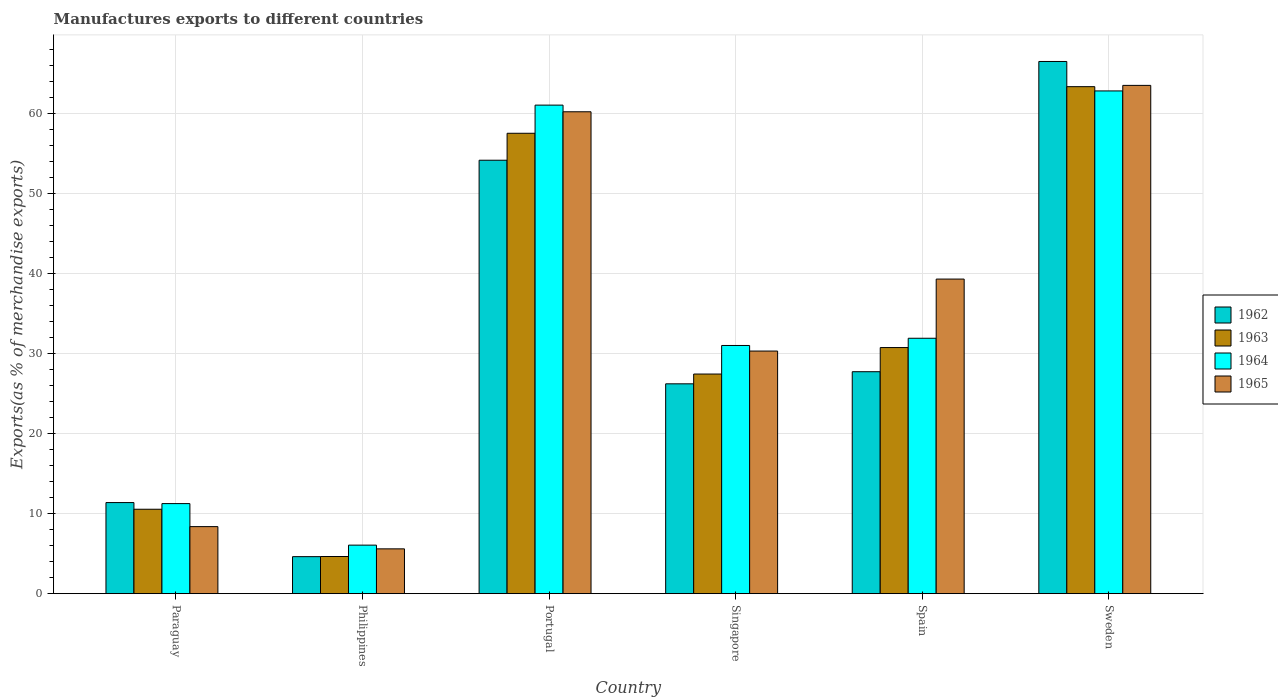How many different coloured bars are there?
Offer a very short reply. 4. How many groups of bars are there?
Provide a succinct answer. 6. Are the number of bars on each tick of the X-axis equal?
Your answer should be compact. Yes. How many bars are there on the 4th tick from the left?
Keep it short and to the point. 4. What is the percentage of exports to different countries in 1964 in Sweden?
Provide a succinct answer. 62.86. Across all countries, what is the maximum percentage of exports to different countries in 1962?
Offer a very short reply. 66.54. Across all countries, what is the minimum percentage of exports to different countries in 1965?
Keep it short and to the point. 5.6. In which country was the percentage of exports to different countries in 1962 minimum?
Your answer should be compact. Philippines. What is the total percentage of exports to different countries in 1965 in the graph?
Your answer should be compact. 207.45. What is the difference between the percentage of exports to different countries in 1965 in Portugal and that in Singapore?
Give a very brief answer. 29.92. What is the difference between the percentage of exports to different countries in 1965 in Philippines and the percentage of exports to different countries in 1964 in Spain?
Your answer should be very brief. -26.33. What is the average percentage of exports to different countries in 1963 per country?
Give a very brief answer. 32.4. What is the difference between the percentage of exports to different countries of/in 1962 and percentage of exports to different countries of/in 1963 in Paraguay?
Keep it short and to the point. 0.83. In how many countries, is the percentage of exports to different countries in 1965 greater than 54 %?
Ensure brevity in your answer.  2. What is the ratio of the percentage of exports to different countries in 1965 in Paraguay to that in Portugal?
Your answer should be very brief. 0.14. Is the difference between the percentage of exports to different countries in 1962 in Portugal and Spain greater than the difference between the percentage of exports to different countries in 1963 in Portugal and Spain?
Provide a short and direct response. No. What is the difference between the highest and the second highest percentage of exports to different countries in 1964?
Your response must be concise. -1.77. What is the difference between the highest and the lowest percentage of exports to different countries in 1963?
Give a very brief answer. 58.74. Is the sum of the percentage of exports to different countries in 1963 in Singapore and Spain greater than the maximum percentage of exports to different countries in 1965 across all countries?
Make the answer very short. No. What does the 4th bar from the left in Singapore represents?
Your response must be concise. 1965. What does the 1st bar from the right in Portugal represents?
Provide a short and direct response. 1965. Is it the case that in every country, the sum of the percentage of exports to different countries in 1962 and percentage of exports to different countries in 1963 is greater than the percentage of exports to different countries in 1965?
Your response must be concise. Yes. Are the values on the major ticks of Y-axis written in scientific E-notation?
Provide a succinct answer. No. Does the graph contain any zero values?
Your answer should be very brief. No. Does the graph contain grids?
Keep it short and to the point. Yes. How are the legend labels stacked?
Your answer should be very brief. Vertical. What is the title of the graph?
Ensure brevity in your answer.  Manufactures exports to different countries. Does "1992" appear as one of the legend labels in the graph?
Make the answer very short. No. What is the label or title of the Y-axis?
Provide a succinct answer. Exports(as % of merchandise exports). What is the Exports(as % of merchandise exports) of 1962 in Paraguay?
Make the answer very short. 11.39. What is the Exports(as % of merchandise exports) of 1963 in Paraguay?
Offer a very short reply. 10.55. What is the Exports(as % of merchandise exports) of 1964 in Paraguay?
Give a very brief answer. 11.26. What is the Exports(as % of merchandise exports) in 1965 in Paraguay?
Provide a short and direct response. 8.38. What is the Exports(as % of merchandise exports) of 1962 in Philippines?
Provide a short and direct response. 4.63. What is the Exports(as % of merchandise exports) in 1963 in Philippines?
Keep it short and to the point. 4.64. What is the Exports(as % of merchandise exports) of 1964 in Philippines?
Keep it short and to the point. 6.07. What is the Exports(as % of merchandise exports) in 1965 in Philippines?
Provide a succinct answer. 5.6. What is the Exports(as % of merchandise exports) in 1962 in Portugal?
Offer a terse response. 54.19. What is the Exports(as % of merchandise exports) in 1963 in Portugal?
Provide a succinct answer. 57.56. What is the Exports(as % of merchandise exports) of 1964 in Portugal?
Keep it short and to the point. 61.08. What is the Exports(as % of merchandise exports) of 1965 in Portugal?
Give a very brief answer. 60.25. What is the Exports(as % of merchandise exports) of 1962 in Singapore?
Provide a short and direct response. 26.24. What is the Exports(as % of merchandise exports) in 1963 in Singapore?
Give a very brief answer. 27.46. What is the Exports(as % of merchandise exports) in 1964 in Singapore?
Offer a very short reply. 31.03. What is the Exports(as % of merchandise exports) in 1965 in Singapore?
Your response must be concise. 30.33. What is the Exports(as % of merchandise exports) in 1962 in Spain?
Offer a very short reply. 27.75. What is the Exports(as % of merchandise exports) in 1963 in Spain?
Offer a very short reply. 30.77. What is the Exports(as % of merchandise exports) of 1964 in Spain?
Offer a very short reply. 31.93. What is the Exports(as % of merchandise exports) in 1965 in Spain?
Provide a succinct answer. 39.33. What is the Exports(as % of merchandise exports) of 1962 in Sweden?
Give a very brief answer. 66.54. What is the Exports(as % of merchandise exports) of 1963 in Sweden?
Your response must be concise. 63.39. What is the Exports(as % of merchandise exports) in 1964 in Sweden?
Ensure brevity in your answer.  62.86. What is the Exports(as % of merchandise exports) in 1965 in Sweden?
Offer a very short reply. 63.55. Across all countries, what is the maximum Exports(as % of merchandise exports) in 1962?
Your answer should be compact. 66.54. Across all countries, what is the maximum Exports(as % of merchandise exports) of 1963?
Offer a very short reply. 63.39. Across all countries, what is the maximum Exports(as % of merchandise exports) of 1964?
Make the answer very short. 62.86. Across all countries, what is the maximum Exports(as % of merchandise exports) of 1965?
Ensure brevity in your answer.  63.55. Across all countries, what is the minimum Exports(as % of merchandise exports) of 1962?
Provide a succinct answer. 4.63. Across all countries, what is the minimum Exports(as % of merchandise exports) of 1963?
Ensure brevity in your answer.  4.64. Across all countries, what is the minimum Exports(as % of merchandise exports) of 1964?
Your answer should be very brief. 6.07. Across all countries, what is the minimum Exports(as % of merchandise exports) of 1965?
Your answer should be compact. 5.6. What is the total Exports(as % of merchandise exports) in 1962 in the graph?
Your response must be concise. 190.73. What is the total Exports(as % of merchandise exports) of 1963 in the graph?
Ensure brevity in your answer.  194.38. What is the total Exports(as % of merchandise exports) in 1964 in the graph?
Offer a terse response. 204.23. What is the total Exports(as % of merchandise exports) of 1965 in the graph?
Your answer should be very brief. 207.45. What is the difference between the Exports(as % of merchandise exports) of 1962 in Paraguay and that in Philippines?
Keep it short and to the point. 6.76. What is the difference between the Exports(as % of merchandise exports) in 1963 in Paraguay and that in Philippines?
Provide a short and direct response. 5.91. What is the difference between the Exports(as % of merchandise exports) of 1964 in Paraguay and that in Philippines?
Your answer should be very brief. 5.19. What is the difference between the Exports(as % of merchandise exports) in 1965 in Paraguay and that in Philippines?
Offer a very short reply. 2.78. What is the difference between the Exports(as % of merchandise exports) in 1962 in Paraguay and that in Portugal?
Keep it short and to the point. -42.8. What is the difference between the Exports(as % of merchandise exports) of 1963 in Paraguay and that in Portugal?
Ensure brevity in your answer.  -47.01. What is the difference between the Exports(as % of merchandise exports) in 1964 in Paraguay and that in Portugal?
Provide a short and direct response. -49.82. What is the difference between the Exports(as % of merchandise exports) of 1965 in Paraguay and that in Portugal?
Ensure brevity in your answer.  -51.87. What is the difference between the Exports(as % of merchandise exports) of 1962 in Paraguay and that in Singapore?
Make the answer very short. -14.85. What is the difference between the Exports(as % of merchandise exports) of 1963 in Paraguay and that in Singapore?
Provide a short and direct response. -16.91. What is the difference between the Exports(as % of merchandise exports) of 1964 in Paraguay and that in Singapore?
Ensure brevity in your answer.  -19.77. What is the difference between the Exports(as % of merchandise exports) of 1965 in Paraguay and that in Singapore?
Ensure brevity in your answer.  -21.95. What is the difference between the Exports(as % of merchandise exports) in 1962 in Paraguay and that in Spain?
Your answer should be very brief. -16.36. What is the difference between the Exports(as % of merchandise exports) of 1963 in Paraguay and that in Spain?
Your answer should be very brief. -20.22. What is the difference between the Exports(as % of merchandise exports) of 1964 in Paraguay and that in Spain?
Your answer should be very brief. -20.67. What is the difference between the Exports(as % of merchandise exports) in 1965 in Paraguay and that in Spain?
Your answer should be very brief. -30.95. What is the difference between the Exports(as % of merchandise exports) of 1962 in Paraguay and that in Sweden?
Offer a terse response. -55.15. What is the difference between the Exports(as % of merchandise exports) in 1963 in Paraguay and that in Sweden?
Offer a terse response. -52.83. What is the difference between the Exports(as % of merchandise exports) of 1964 in Paraguay and that in Sweden?
Ensure brevity in your answer.  -51.6. What is the difference between the Exports(as % of merchandise exports) in 1965 in Paraguay and that in Sweden?
Your response must be concise. -55.17. What is the difference between the Exports(as % of merchandise exports) of 1962 in Philippines and that in Portugal?
Your answer should be compact. -49.57. What is the difference between the Exports(as % of merchandise exports) of 1963 in Philippines and that in Portugal?
Provide a short and direct response. -52.92. What is the difference between the Exports(as % of merchandise exports) of 1964 in Philippines and that in Portugal?
Make the answer very short. -55.02. What is the difference between the Exports(as % of merchandise exports) of 1965 in Philippines and that in Portugal?
Keep it short and to the point. -54.65. What is the difference between the Exports(as % of merchandise exports) in 1962 in Philippines and that in Singapore?
Provide a succinct answer. -21.61. What is the difference between the Exports(as % of merchandise exports) in 1963 in Philippines and that in Singapore?
Your answer should be very brief. -22.82. What is the difference between the Exports(as % of merchandise exports) in 1964 in Philippines and that in Singapore?
Offer a terse response. -24.96. What is the difference between the Exports(as % of merchandise exports) of 1965 in Philippines and that in Singapore?
Provide a short and direct response. -24.73. What is the difference between the Exports(as % of merchandise exports) of 1962 in Philippines and that in Spain?
Your answer should be very brief. -23.12. What is the difference between the Exports(as % of merchandise exports) in 1963 in Philippines and that in Spain?
Provide a succinct answer. -26.13. What is the difference between the Exports(as % of merchandise exports) of 1964 in Philippines and that in Spain?
Your response must be concise. -25.87. What is the difference between the Exports(as % of merchandise exports) of 1965 in Philippines and that in Spain?
Ensure brevity in your answer.  -33.73. What is the difference between the Exports(as % of merchandise exports) of 1962 in Philippines and that in Sweden?
Your response must be concise. -61.91. What is the difference between the Exports(as % of merchandise exports) in 1963 in Philippines and that in Sweden?
Your response must be concise. -58.74. What is the difference between the Exports(as % of merchandise exports) in 1964 in Philippines and that in Sweden?
Provide a short and direct response. -56.79. What is the difference between the Exports(as % of merchandise exports) of 1965 in Philippines and that in Sweden?
Provide a short and direct response. -57.95. What is the difference between the Exports(as % of merchandise exports) of 1962 in Portugal and that in Singapore?
Provide a short and direct response. 27.96. What is the difference between the Exports(as % of merchandise exports) in 1963 in Portugal and that in Singapore?
Ensure brevity in your answer.  30.1. What is the difference between the Exports(as % of merchandise exports) in 1964 in Portugal and that in Singapore?
Keep it short and to the point. 30.05. What is the difference between the Exports(as % of merchandise exports) of 1965 in Portugal and that in Singapore?
Your answer should be compact. 29.92. What is the difference between the Exports(as % of merchandise exports) of 1962 in Portugal and that in Spain?
Provide a short and direct response. 26.44. What is the difference between the Exports(as % of merchandise exports) in 1963 in Portugal and that in Spain?
Ensure brevity in your answer.  26.79. What is the difference between the Exports(as % of merchandise exports) of 1964 in Portugal and that in Spain?
Provide a short and direct response. 29.15. What is the difference between the Exports(as % of merchandise exports) in 1965 in Portugal and that in Spain?
Provide a short and direct response. 20.92. What is the difference between the Exports(as % of merchandise exports) in 1962 in Portugal and that in Sweden?
Your response must be concise. -12.35. What is the difference between the Exports(as % of merchandise exports) in 1963 in Portugal and that in Sweden?
Your answer should be compact. -5.83. What is the difference between the Exports(as % of merchandise exports) of 1964 in Portugal and that in Sweden?
Your answer should be very brief. -1.77. What is the difference between the Exports(as % of merchandise exports) in 1965 in Portugal and that in Sweden?
Provide a short and direct response. -3.3. What is the difference between the Exports(as % of merchandise exports) of 1962 in Singapore and that in Spain?
Ensure brevity in your answer.  -1.51. What is the difference between the Exports(as % of merchandise exports) in 1963 in Singapore and that in Spain?
Your response must be concise. -3.31. What is the difference between the Exports(as % of merchandise exports) of 1964 in Singapore and that in Spain?
Provide a short and direct response. -0.9. What is the difference between the Exports(as % of merchandise exports) in 1965 in Singapore and that in Spain?
Your response must be concise. -9. What is the difference between the Exports(as % of merchandise exports) in 1962 in Singapore and that in Sweden?
Provide a short and direct response. -40.3. What is the difference between the Exports(as % of merchandise exports) in 1963 in Singapore and that in Sweden?
Offer a very short reply. -35.93. What is the difference between the Exports(as % of merchandise exports) of 1964 in Singapore and that in Sweden?
Offer a very short reply. -31.83. What is the difference between the Exports(as % of merchandise exports) of 1965 in Singapore and that in Sweden?
Offer a very short reply. -33.22. What is the difference between the Exports(as % of merchandise exports) in 1962 in Spain and that in Sweden?
Provide a succinct answer. -38.79. What is the difference between the Exports(as % of merchandise exports) in 1963 in Spain and that in Sweden?
Give a very brief answer. -32.62. What is the difference between the Exports(as % of merchandise exports) in 1964 in Spain and that in Sweden?
Offer a very short reply. -30.92. What is the difference between the Exports(as % of merchandise exports) of 1965 in Spain and that in Sweden?
Your answer should be compact. -24.22. What is the difference between the Exports(as % of merchandise exports) in 1962 in Paraguay and the Exports(as % of merchandise exports) in 1963 in Philippines?
Keep it short and to the point. 6.75. What is the difference between the Exports(as % of merchandise exports) of 1962 in Paraguay and the Exports(as % of merchandise exports) of 1964 in Philippines?
Provide a short and direct response. 5.32. What is the difference between the Exports(as % of merchandise exports) of 1962 in Paraguay and the Exports(as % of merchandise exports) of 1965 in Philippines?
Provide a succinct answer. 5.79. What is the difference between the Exports(as % of merchandise exports) in 1963 in Paraguay and the Exports(as % of merchandise exports) in 1964 in Philippines?
Your answer should be compact. 4.49. What is the difference between the Exports(as % of merchandise exports) in 1963 in Paraguay and the Exports(as % of merchandise exports) in 1965 in Philippines?
Offer a terse response. 4.95. What is the difference between the Exports(as % of merchandise exports) of 1964 in Paraguay and the Exports(as % of merchandise exports) of 1965 in Philippines?
Provide a short and direct response. 5.66. What is the difference between the Exports(as % of merchandise exports) of 1962 in Paraguay and the Exports(as % of merchandise exports) of 1963 in Portugal?
Provide a succinct answer. -46.17. What is the difference between the Exports(as % of merchandise exports) in 1962 in Paraguay and the Exports(as % of merchandise exports) in 1964 in Portugal?
Your answer should be compact. -49.69. What is the difference between the Exports(as % of merchandise exports) of 1962 in Paraguay and the Exports(as % of merchandise exports) of 1965 in Portugal?
Provide a short and direct response. -48.86. What is the difference between the Exports(as % of merchandise exports) in 1963 in Paraguay and the Exports(as % of merchandise exports) in 1964 in Portugal?
Your answer should be compact. -50.53. What is the difference between the Exports(as % of merchandise exports) in 1963 in Paraguay and the Exports(as % of merchandise exports) in 1965 in Portugal?
Keep it short and to the point. -49.7. What is the difference between the Exports(as % of merchandise exports) in 1964 in Paraguay and the Exports(as % of merchandise exports) in 1965 in Portugal?
Your response must be concise. -48.99. What is the difference between the Exports(as % of merchandise exports) of 1962 in Paraguay and the Exports(as % of merchandise exports) of 1963 in Singapore?
Give a very brief answer. -16.07. What is the difference between the Exports(as % of merchandise exports) in 1962 in Paraguay and the Exports(as % of merchandise exports) in 1964 in Singapore?
Offer a very short reply. -19.64. What is the difference between the Exports(as % of merchandise exports) in 1962 in Paraguay and the Exports(as % of merchandise exports) in 1965 in Singapore?
Your response must be concise. -18.94. What is the difference between the Exports(as % of merchandise exports) in 1963 in Paraguay and the Exports(as % of merchandise exports) in 1964 in Singapore?
Your answer should be very brief. -20.48. What is the difference between the Exports(as % of merchandise exports) of 1963 in Paraguay and the Exports(as % of merchandise exports) of 1965 in Singapore?
Provide a short and direct response. -19.78. What is the difference between the Exports(as % of merchandise exports) in 1964 in Paraguay and the Exports(as % of merchandise exports) in 1965 in Singapore?
Offer a very short reply. -19.07. What is the difference between the Exports(as % of merchandise exports) of 1962 in Paraguay and the Exports(as % of merchandise exports) of 1963 in Spain?
Keep it short and to the point. -19.38. What is the difference between the Exports(as % of merchandise exports) in 1962 in Paraguay and the Exports(as % of merchandise exports) in 1964 in Spain?
Provide a short and direct response. -20.54. What is the difference between the Exports(as % of merchandise exports) in 1962 in Paraguay and the Exports(as % of merchandise exports) in 1965 in Spain?
Your answer should be very brief. -27.94. What is the difference between the Exports(as % of merchandise exports) of 1963 in Paraguay and the Exports(as % of merchandise exports) of 1964 in Spain?
Your answer should be very brief. -21.38. What is the difference between the Exports(as % of merchandise exports) of 1963 in Paraguay and the Exports(as % of merchandise exports) of 1965 in Spain?
Provide a succinct answer. -28.78. What is the difference between the Exports(as % of merchandise exports) in 1964 in Paraguay and the Exports(as % of merchandise exports) in 1965 in Spain?
Provide a succinct answer. -28.07. What is the difference between the Exports(as % of merchandise exports) in 1962 in Paraguay and the Exports(as % of merchandise exports) in 1963 in Sweden?
Keep it short and to the point. -52. What is the difference between the Exports(as % of merchandise exports) in 1962 in Paraguay and the Exports(as % of merchandise exports) in 1964 in Sweden?
Make the answer very short. -51.47. What is the difference between the Exports(as % of merchandise exports) of 1962 in Paraguay and the Exports(as % of merchandise exports) of 1965 in Sweden?
Offer a terse response. -52.16. What is the difference between the Exports(as % of merchandise exports) of 1963 in Paraguay and the Exports(as % of merchandise exports) of 1964 in Sweden?
Provide a short and direct response. -52.3. What is the difference between the Exports(as % of merchandise exports) in 1963 in Paraguay and the Exports(as % of merchandise exports) in 1965 in Sweden?
Offer a terse response. -52.99. What is the difference between the Exports(as % of merchandise exports) of 1964 in Paraguay and the Exports(as % of merchandise exports) of 1965 in Sweden?
Provide a short and direct response. -52.29. What is the difference between the Exports(as % of merchandise exports) of 1962 in Philippines and the Exports(as % of merchandise exports) of 1963 in Portugal?
Your answer should be compact. -52.93. What is the difference between the Exports(as % of merchandise exports) in 1962 in Philippines and the Exports(as % of merchandise exports) in 1964 in Portugal?
Ensure brevity in your answer.  -56.46. What is the difference between the Exports(as % of merchandise exports) in 1962 in Philippines and the Exports(as % of merchandise exports) in 1965 in Portugal?
Offer a very short reply. -55.62. What is the difference between the Exports(as % of merchandise exports) of 1963 in Philippines and the Exports(as % of merchandise exports) of 1964 in Portugal?
Make the answer very short. -56.44. What is the difference between the Exports(as % of merchandise exports) in 1963 in Philippines and the Exports(as % of merchandise exports) in 1965 in Portugal?
Offer a very short reply. -55.61. What is the difference between the Exports(as % of merchandise exports) of 1964 in Philippines and the Exports(as % of merchandise exports) of 1965 in Portugal?
Ensure brevity in your answer.  -54.18. What is the difference between the Exports(as % of merchandise exports) of 1962 in Philippines and the Exports(as % of merchandise exports) of 1963 in Singapore?
Provide a short and direct response. -22.83. What is the difference between the Exports(as % of merchandise exports) of 1962 in Philippines and the Exports(as % of merchandise exports) of 1964 in Singapore?
Provide a succinct answer. -26.4. What is the difference between the Exports(as % of merchandise exports) of 1962 in Philippines and the Exports(as % of merchandise exports) of 1965 in Singapore?
Your answer should be compact. -25.7. What is the difference between the Exports(as % of merchandise exports) in 1963 in Philippines and the Exports(as % of merchandise exports) in 1964 in Singapore?
Provide a short and direct response. -26.39. What is the difference between the Exports(as % of merchandise exports) in 1963 in Philippines and the Exports(as % of merchandise exports) in 1965 in Singapore?
Provide a short and direct response. -25.69. What is the difference between the Exports(as % of merchandise exports) in 1964 in Philippines and the Exports(as % of merchandise exports) in 1965 in Singapore?
Provide a succinct answer. -24.27. What is the difference between the Exports(as % of merchandise exports) of 1962 in Philippines and the Exports(as % of merchandise exports) of 1963 in Spain?
Provide a short and direct response. -26.14. What is the difference between the Exports(as % of merchandise exports) of 1962 in Philippines and the Exports(as % of merchandise exports) of 1964 in Spain?
Keep it short and to the point. -27.31. What is the difference between the Exports(as % of merchandise exports) of 1962 in Philippines and the Exports(as % of merchandise exports) of 1965 in Spain?
Give a very brief answer. -34.71. What is the difference between the Exports(as % of merchandise exports) of 1963 in Philippines and the Exports(as % of merchandise exports) of 1964 in Spain?
Give a very brief answer. -27.29. What is the difference between the Exports(as % of merchandise exports) of 1963 in Philippines and the Exports(as % of merchandise exports) of 1965 in Spain?
Make the answer very short. -34.69. What is the difference between the Exports(as % of merchandise exports) of 1964 in Philippines and the Exports(as % of merchandise exports) of 1965 in Spain?
Offer a very short reply. -33.27. What is the difference between the Exports(as % of merchandise exports) in 1962 in Philippines and the Exports(as % of merchandise exports) in 1963 in Sweden?
Make the answer very short. -58.76. What is the difference between the Exports(as % of merchandise exports) in 1962 in Philippines and the Exports(as % of merchandise exports) in 1964 in Sweden?
Provide a succinct answer. -58.23. What is the difference between the Exports(as % of merchandise exports) in 1962 in Philippines and the Exports(as % of merchandise exports) in 1965 in Sweden?
Give a very brief answer. -58.92. What is the difference between the Exports(as % of merchandise exports) in 1963 in Philippines and the Exports(as % of merchandise exports) in 1964 in Sweden?
Give a very brief answer. -58.21. What is the difference between the Exports(as % of merchandise exports) of 1963 in Philippines and the Exports(as % of merchandise exports) of 1965 in Sweden?
Provide a succinct answer. -58.91. What is the difference between the Exports(as % of merchandise exports) of 1964 in Philippines and the Exports(as % of merchandise exports) of 1965 in Sweden?
Your response must be concise. -57.48. What is the difference between the Exports(as % of merchandise exports) in 1962 in Portugal and the Exports(as % of merchandise exports) in 1963 in Singapore?
Provide a succinct answer. 26.73. What is the difference between the Exports(as % of merchandise exports) in 1962 in Portugal and the Exports(as % of merchandise exports) in 1964 in Singapore?
Your answer should be very brief. 23.16. What is the difference between the Exports(as % of merchandise exports) of 1962 in Portugal and the Exports(as % of merchandise exports) of 1965 in Singapore?
Your answer should be compact. 23.86. What is the difference between the Exports(as % of merchandise exports) of 1963 in Portugal and the Exports(as % of merchandise exports) of 1964 in Singapore?
Offer a very short reply. 26.53. What is the difference between the Exports(as % of merchandise exports) of 1963 in Portugal and the Exports(as % of merchandise exports) of 1965 in Singapore?
Offer a very short reply. 27.23. What is the difference between the Exports(as % of merchandise exports) of 1964 in Portugal and the Exports(as % of merchandise exports) of 1965 in Singapore?
Offer a terse response. 30.75. What is the difference between the Exports(as % of merchandise exports) in 1962 in Portugal and the Exports(as % of merchandise exports) in 1963 in Spain?
Your answer should be very brief. 23.42. What is the difference between the Exports(as % of merchandise exports) in 1962 in Portugal and the Exports(as % of merchandise exports) in 1964 in Spain?
Keep it short and to the point. 22.26. What is the difference between the Exports(as % of merchandise exports) in 1962 in Portugal and the Exports(as % of merchandise exports) in 1965 in Spain?
Offer a very short reply. 14.86. What is the difference between the Exports(as % of merchandise exports) in 1963 in Portugal and the Exports(as % of merchandise exports) in 1964 in Spain?
Your answer should be very brief. 25.63. What is the difference between the Exports(as % of merchandise exports) of 1963 in Portugal and the Exports(as % of merchandise exports) of 1965 in Spain?
Provide a short and direct response. 18.23. What is the difference between the Exports(as % of merchandise exports) in 1964 in Portugal and the Exports(as % of merchandise exports) in 1965 in Spain?
Keep it short and to the point. 21.75. What is the difference between the Exports(as % of merchandise exports) of 1962 in Portugal and the Exports(as % of merchandise exports) of 1963 in Sweden?
Make the answer very short. -9.2. What is the difference between the Exports(as % of merchandise exports) of 1962 in Portugal and the Exports(as % of merchandise exports) of 1964 in Sweden?
Ensure brevity in your answer.  -8.66. What is the difference between the Exports(as % of merchandise exports) in 1962 in Portugal and the Exports(as % of merchandise exports) in 1965 in Sweden?
Offer a terse response. -9.36. What is the difference between the Exports(as % of merchandise exports) in 1963 in Portugal and the Exports(as % of merchandise exports) in 1964 in Sweden?
Offer a terse response. -5.3. What is the difference between the Exports(as % of merchandise exports) of 1963 in Portugal and the Exports(as % of merchandise exports) of 1965 in Sweden?
Provide a succinct answer. -5.99. What is the difference between the Exports(as % of merchandise exports) of 1964 in Portugal and the Exports(as % of merchandise exports) of 1965 in Sweden?
Ensure brevity in your answer.  -2.47. What is the difference between the Exports(as % of merchandise exports) of 1962 in Singapore and the Exports(as % of merchandise exports) of 1963 in Spain?
Provide a short and direct response. -4.53. What is the difference between the Exports(as % of merchandise exports) of 1962 in Singapore and the Exports(as % of merchandise exports) of 1964 in Spain?
Make the answer very short. -5.7. What is the difference between the Exports(as % of merchandise exports) of 1962 in Singapore and the Exports(as % of merchandise exports) of 1965 in Spain?
Your answer should be very brief. -13.1. What is the difference between the Exports(as % of merchandise exports) of 1963 in Singapore and the Exports(as % of merchandise exports) of 1964 in Spain?
Offer a very short reply. -4.47. What is the difference between the Exports(as % of merchandise exports) of 1963 in Singapore and the Exports(as % of merchandise exports) of 1965 in Spain?
Give a very brief answer. -11.87. What is the difference between the Exports(as % of merchandise exports) of 1964 in Singapore and the Exports(as % of merchandise exports) of 1965 in Spain?
Keep it short and to the point. -8.3. What is the difference between the Exports(as % of merchandise exports) in 1962 in Singapore and the Exports(as % of merchandise exports) in 1963 in Sweden?
Your response must be concise. -37.15. What is the difference between the Exports(as % of merchandise exports) in 1962 in Singapore and the Exports(as % of merchandise exports) in 1964 in Sweden?
Offer a terse response. -36.62. What is the difference between the Exports(as % of merchandise exports) of 1962 in Singapore and the Exports(as % of merchandise exports) of 1965 in Sweden?
Keep it short and to the point. -37.31. What is the difference between the Exports(as % of merchandise exports) of 1963 in Singapore and the Exports(as % of merchandise exports) of 1964 in Sweden?
Give a very brief answer. -35.4. What is the difference between the Exports(as % of merchandise exports) in 1963 in Singapore and the Exports(as % of merchandise exports) in 1965 in Sweden?
Keep it short and to the point. -36.09. What is the difference between the Exports(as % of merchandise exports) in 1964 in Singapore and the Exports(as % of merchandise exports) in 1965 in Sweden?
Provide a succinct answer. -32.52. What is the difference between the Exports(as % of merchandise exports) of 1962 in Spain and the Exports(as % of merchandise exports) of 1963 in Sweden?
Provide a short and direct response. -35.64. What is the difference between the Exports(as % of merchandise exports) in 1962 in Spain and the Exports(as % of merchandise exports) in 1964 in Sweden?
Your response must be concise. -35.11. What is the difference between the Exports(as % of merchandise exports) in 1962 in Spain and the Exports(as % of merchandise exports) in 1965 in Sweden?
Give a very brief answer. -35.8. What is the difference between the Exports(as % of merchandise exports) in 1963 in Spain and the Exports(as % of merchandise exports) in 1964 in Sweden?
Your answer should be compact. -32.09. What is the difference between the Exports(as % of merchandise exports) of 1963 in Spain and the Exports(as % of merchandise exports) of 1965 in Sweden?
Provide a succinct answer. -32.78. What is the difference between the Exports(as % of merchandise exports) of 1964 in Spain and the Exports(as % of merchandise exports) of 1965 in Sweden?
Ensure brevity in your answer.  -31.62. What is the average Exports(as % of merchandise exports) of 1962 per country?
Provide a short and direct response. 31.79. What is the average Exports(as % of merchandise exports) of 1963 per country?
Provide a succinct answer. 32.4. What is the average Exports(as % of merchandise exports) of 1964 per country?
Keep it short and to the point. 34.04. What is the average Exports(as % of merchandise exports) of 1965 per country?
Ensure brevity in your answer.  34.57. What is the difference between the Exports(as % of merchandise exports) in 1962 and Exports(as % of merchandise exports) in 1963 in Paraguay?
Offer a terse response. 0.83. What is the difference between the Exports(as % of merchandise exports) of 1962 and Exports(as % of merchandise exports) of 1964 in Paraguay?
Your answer should be very brief. 0.13. What is the difference between the Exports(as % of merchandise exports) in 1962 and Exports(as % of merchandise exports) in 1965 in Paraguay?
Give a very brief answer. 3.01. What is the difference between the Exports(as % of merchandise exports) in 1963 and Exports(as % of merchandise exports) in 1964 in Paraguay?
Give a very brief answer. -0.71. What is the difference between the Exports(as % of merchandise exports) in 1963 and Exports(as % of merchandise exports) in 1965 in Paraguay?
Your answer should be very brief. 2.17. What is the difference between the Exports(as % of merchandise exports) in 1964 and Exports(as % of merchandise exports) in 1965 in Paraguay?
Your answer should be compact. 2.88. What is the difference between the Exports(as % of merchandise exports) in 1962 and Exports(as % of merchandise exports) in 1963 in Philippines?
Make the answer very short. -0.02. What is the difference between the Exports(as % of merchandise exports) in 1962 and Exports(as % of merchandise exports) in 1964 in Philippines?
Give a very brief answer. -1.44. What is the difference between the Exports(as % of merchandise exports) in 1962 and Exports(as % of merchandise exports) in 1965 in Philippines?
Your answer should be very brief. -0.98. What is the difference between the Exports(as % of merchandise exports) of 1963 and Exports(as % of merchandise exports) of 1964 in Philippines?
Provide a succinct answer. -1.42. What is the difference between the Exports(as % of merchandise exports) of 1963 and Exports(as % of merchandise exports) of 1965 in Philippines?
Your answer should be compact. -0.96. What is the difference between the Exports(as % of merchandise exports) of 1964 and Exports(as % of merchandise exports) of 1965 in Philippines?
Your response must be concise. 0.46. What is the difference between the Exports(as % of merchandise exports) of 1962 and Exports(as % of merchandise exports) of 1963 in Portugal?
Provide a succinct answer. -3.37. What is the difference between the Exports(as % of merchandise exports) of 1962 and Exports(as % of merchandise exports) of 1964 in Portugal?
Keep it short and to the point. -6.89. What is the difference between the Exports(as % of merchandise exports) in 1962 and Exports(as % of merchandise exports) in 1965 in Portugal?
Ensure brevity in your answer.  -6.06. What is the difference between the Exports(as % of merchandise exports) of 1963 and Exports(as % of merchandise exports) of 1964 in Portugal?
Ensure brevity in your answer.  -3.52. What is the difference between the Exports(as % of merchandise exports) in 1963 and Exports(as % of merchandise exports) in 1965 in Portugal?
Ensure brevity in your answer.  -2.69. What is the difference between the Exports(as % of merchandise exports) of 1964 and Exports(as % of merchandise exports) of 1965 in Portugal?
Keep it short and to the point. 0.83. What is the difference between the Exports(as % of merchandise exports) in 1962 and Exports(as % of merchandise exports) in 1963 in Singapore?
Ensure brevity in your answer.  -1.22. What is the difference between the Exports(as % of merchandise exports) in 1962 and Exports(as % of merchandise exports) in 1964 in Singapore?
Your response must be concise. -4.79. What is the difference between the Exports(as % of merchandise exports) of 1962 and Exports(as % of merchandise exports) of 1965 in Singapore?
Your answer should be compact. -4.1. What is the difference between the Exports(as % of merchandise exports) of 1963 and Exports(as % of merchandise exports) of 1964 in Singapore?
Make the answer very short. -3.57. What is the difference between the Exports(as % of merchandise exports) of 1963 and Exports(as % of merchandise exports) of 1965 in Singapore?
Your response must be concise. -2.87. What is the difference between the Exports(as % of merchandise exports) in 1964 and Exports(as % of merchandise exports) in 1965 in Singapore?
Ensure brevity in your answer.  0.7. What is the difference between the Exports(as % of merchandise exports) of 1962 and Exports(as % of merchandise exports) of 1963 in Spain?
Your response must be concise. -3.02. What is the difference between the Exports(as % of merchandise exports) in 1962 and Exports(as % of merchandise exports) in 1964 in Spain?
Give a very brief answer. -4.18. What is the difference between the Exports(as % of merchandise exports) in 1962 and Exports(as % of merchandise exports) in 1965 in Spain?
Provide a short and direct response. -11.58. What is the difference between the Exports(as % of merchandise exports) of 1963 and Exports(as % of merchandise exports) of 1964 in Spain?
Keep it short and to the point. -1.16. What is the difference between the Exports(as % of merchandise exports) in 1963 and Exports(as % of merchandise exports) in 1965 in Spain?
Offer a terse response. -8.56. What is the difference between the Exports(as % of merchandise exports) in 1964 and Exports(as % of merchandise exports) in 1965 in Spain?
Offer a very short reply. -7.4. What is the difference between the Exports(as % of merchandise exports) in 1962 and Exports(as % of merchandise exports) in 1963 in Sweden?
Your answer should be very brief. 3.15. What is the difference between the Exports(as % of merchandise exports) of 1962 and Exports(as % of merchandise exports) of 1964 in Sweden?
Provide a succinct answer. 3.68. What is the difference between the Exports(as % of merchandise exports) of 1962 and Exports(as % of merchandise exports) of 1965 in Sweden?
Ensure brevity in your answer.  2.99. What is the difference between the Exports(as % of merchandise exports) in 1963 and Exports(as % of merchandise exports) in 1964 in Sweden?
Make the answer very short. 0.53. What is the difference between the Exports(as % of merchandise exports) of 1963 and Exports(as % of merchandise exports) of 1965 in Sweden?
Make the answer very short. -0.16. What is the difference between the Exports(as % of merchandise exports) in 1964 and Exports(as % of merchandise exports) in 1965 in Sweden?
Provide a succinct answer. -0.69. What is the ratio of the Exports(as % of merchandise exports) in 1962 in Paraguay to that in Philippines?
Offer a terse response. 2.46. What is the ratio of the Exports(as % of merchandise exports) in 1963 in Paraguay to that in Philippines?
Offer a terse response. 2.27. What is the ratio of the Exports(as % of merchandise exports) of 1964 in Paraguay to that in Philippines?
Give a very brief answer. 1.86. What is the ratio of the Exports(as % of merchandise exports) in 1965 in Paraguay to that in Philippines?
Your response must be concise. 1.5. What is the ratio of the Exports(as % of merchandise exports) of 1962 in Paraguay to that in Portugal?
Keep it short and to the point. 0.21. What is the ratio of the Exports(as % of merchandise exports) in 1963 in Paraguay to that in Portugal?
Provide a succinct answer. 0.18. What is the ratio of the Exports(as % of merchandise exports) in 1964 in Paraguay to that in Portugal?
Ensure brevity in your answer.  0.18. What is the ratio of the Exports(as % of merchandise exports) in 1965 in Paraguay to that in Portugal?
Provide a short and direct response. 0.14. What is the ratio of the Exports(as % of merchandise exports) of 1962 in Paraguay to that in Singapore?
Give a very brief answer. 0.43. What is the ratio of the Exports(as % of merchandise exports) of 1963 in Paraguay to that in Singapore?
Make the answer very short. 0.38. What is the ratio of the Exports(as % of merchandise exports) of 1964 in Paraguay to that in Singapore?
Ensure brevity in your answer.  0.36. What is the ratio of the Exports(as % of merchandise exports) in 1965 in Paraguay to that in Singapore?
Ensure brevity in your answer.  0.28. What is the ratio of the Exports(as % of merchandise exports) in 1962 in Paraguay to that in Spain?
Your answer should be compact. 0.41. What is the ratio of the Exports(as % of merchandise exports) of 1963 in Paraguay to that in Spain?
Offer a terse response. 0.34. What is the ratio of the Exports(as % of merchandise exports) of 1964 in Paraguay to that in Spain?
Provide a succinct answer. 0.35. What is the ratio of the Exports(as % of merchandise exports) in 1965 in Paraguay to that in Spain?
Your answer should be very brief. 0.21. What is the ratio of the Exports(as % of merchandise exports) of 1962 in Paraguay to that in Sweden?
Offer a terse response. 0.17. What is the ratio of the Exports(as % of merchandise exports) of 1963 in Paraguay to that in Sweden?
Your answer should be compact. 0.17. What is the ratio of the Exports(as % of merchandise exports) of 1964 in Paraguay to that in Sweden?
Your answer should be very brief. 0.18. What is the ratio of the Exports(as % of merchandise exports) of 1965 in Paraguay to that in Sweden?
Your answer should be compact. 0.13. What is the ratio of the Exports(as % of merchandise exports) of 1962 in Philippines to that in Portugal?
Your answer should be compact. 0.09. What is the ratio of the Exports(as % of merchandise exports) of 1963 in Philippines to that in Portugal?
Provide a short and direct response. 0.08. What is the ratio of the Exports(as % of merchandise exports) of 1964 in Philippines to that in Portugal?
Your answer should be compact. 0.1. What is the ratio of the Exports(as % of merchandise exports) of 1965 in Philippines to that in Portugal?
Your response must be concise. 0.09. What is the ratio of the Exports(as % of merchandise exports) in 1962 in Philippines to that in Singapore?
Offer a terse response. 0.18. What is the ratio of the Exports(as % of merchandise exports) of 1963 in Philippines to that in Singapore?
Make the answer very short. 0.17. What is the ratio of the Exports(as % of merchandise exports) of 1964 in Philippines to that in Singapore?
Your response must be concise. 0.2. What is the ratio of the Exports(as % of merchandise exports) in 1965 in Philippines to that in Singapore?
Your response must be concise. 0.18. What is the ratio of the Exports(as % of merchandise exports) of 1962 in Philippines to that in Spain?
Offer a terse response. 0.17. What is the ratio of the Exports(as % of merchandise exports) in 1963 in Philippines to that in Spain?
Provide a short and direct response. 0.15. What is the ratio of the Exports(as % of merchandise exports) in 1964 in Philippines to that in Spain?
Provide a short and direct response. 0.19. What is the ratio of the Exports(as % of merchandise exports) of 1965 in Philippines to that in Spain?
Make the answer very short. 0.14. What is the ratio of the Exports(as % of merchandise exports) of 1962 in Philippines to that in Sweden?
Provide a succinct answer. 0.07. What is the ratio of the Exports(as % of merchandise exports) in 1963 in Philippines to that in Sweden?
Offer a very short reply. 0.07. What is the ratio of the Exports(as % of merchandise exports) of 1964 in Philippines to that in Sweden?
Offer a very short reply. 0.1. What is the ratio of the Exports(as % of merchandise exports) in 1965 in Philippines to that in Sweden?
Make the answer very short. 0.09. What is the ratio of the Exports(as % of merchandise exports) of 1962 in Portugal to that in Singapore?
Provide a short and direct response. 2.07. What is the ratio of the Exports(as % of merchandise exports) of 1963 in Portugal to that in Singapore?
Your response must be concise. 2.1. What is the ratio of the Exports(as % of merchandise exports) of 1964 in Portugal to that in Singapore?
Ensure brevity in your answer.  1.97. What is the ratio of the Exports(as % of merchandise exports) in 1965 in Portugal to that in Singapore?
Keep it short and to the point. 1.99. What is the ratio of the Exports(as % of merchandise exports) of 1962 in Portugal to that in Spain?
Your answer should be compact. 1.95. What is the ratio of the Exports(as % of merchandise exports) in 1963 in Portugal to that in Spain?
Keep it short and to the point. 1.87. What is the ratio of the Exports(as % of merchandise exports) of 1964 in Portugal to that in Spain?
Give a very brief answer. 1.91. What is the ratio of the Exports(as % of merchandise exports) in 1965 in Portugal to that in Spain?
Your answer should be compact. 1.53. What is the ratio of the Exports(as % of merchandise exports) in 1962 in Portugal to that in Sweden?
Make the answer very short. 0.81. What is the ratio of the Exports(as % of merchandise exports) in 1963 in Portugal to that in Sweden?
Your response must be concise. 0.91. What is the ratio of the Exports(as % of merchandise exports) of 1964 in Portugal to that in Sweden?
Keep it short and to the point. 0.97. What is the ratio of the Exports(as % of merchandise exports) in 1965 in Portugal to that in Sweden?
Make the answer very short. 0.95. What is the ratio of the Exports(as % of merchandise exports) of 1962 in Singapore to that in Spain?
Give a very brief answer. 0.95. What is the ratio of the Exports(as % of merchandise exports) of 1963 in Singapore to that in Spain?
Keep it short and to the point. 0.89. What is the ratio of the Exports(as % of merchandise exports) of 1964 in Singapore to that in Spain?
Give a very brief answer. 0.97. What is the ratio of the Exports(as % of merchandise exports) of 1965 in Singapore to that in Spain?
Your answer should be compact. 0.77. What is the ratio of the Exports(as % of merchandise exports) in 1962 in Singapore to that in Sweden?
Keep it short and to the point. 0.39. What is the ratio of the Exports(as % of merchandise exports) in 1963 in Singapore to that in Sweden?
Make the answer very short. 0.43. What is the ratio of the Exports(as % of merchandise exports) of 1964 in Singapore to that in Sweden?
Keep it short and to the point. 0.49. What is the ratio of the Exports(as % of merchandise exports) of 1965 in Singapore to that in Sweden?
Give a very brief answer. 0.48. What is the ratio of the Exports(as % of merchandise exports) in 1962 in Spain to that in Sweden?
Provide a succinct answer. 0.42. What is the ratio of the Exports(as % of merchandise exports) of 1963 in Spain to that in Sweden?
Your response must be concise. 0.49. What is the ratio of the Exports(as % of merchandise exports) of 1964 in Spain to that in Sweden?
Your response must be concise. 0.51. What is the ratio of the Exports(as % of merchandise exports) of 1965 in Spain to that in Sweden?
Your answer should be very brief. 0.62. What is the difference between the highest and the second highest Exports(as % of merchandise exports) in 1962?
Your answer should be very brief. 12.35. What is the difference between the highest and the second highest Exports(as % of merchandise exports) of 1963?
Your response must be concise. 5.83. What is the difference between the highest and the second highest Exports(as % of merchandise exports) of 1964?
Offer a terse response. 1.77. What is the difference between the highest and the second highest Exports(as % of merchandise exports) in 1965?
Your response must be concise. 3.3. What is the difference between the highest and the lowest Exports(as % of merchandise exports) of 1962?
Your answer should be very brief. 61.91. What is the difference between the highest and the lowest Exports(as % of merchandise exports) in 1963?
Your answer should be compact. 58.74. What is the difference between the highest and the lowest Exports(as % of merchandise exports) in 1964?
Give a very brief answer. 56.79. What is the difference between the highest and the lowest Exports(as % of merchandise exports) of 1965?
Offer a very short reply. 57.95. 